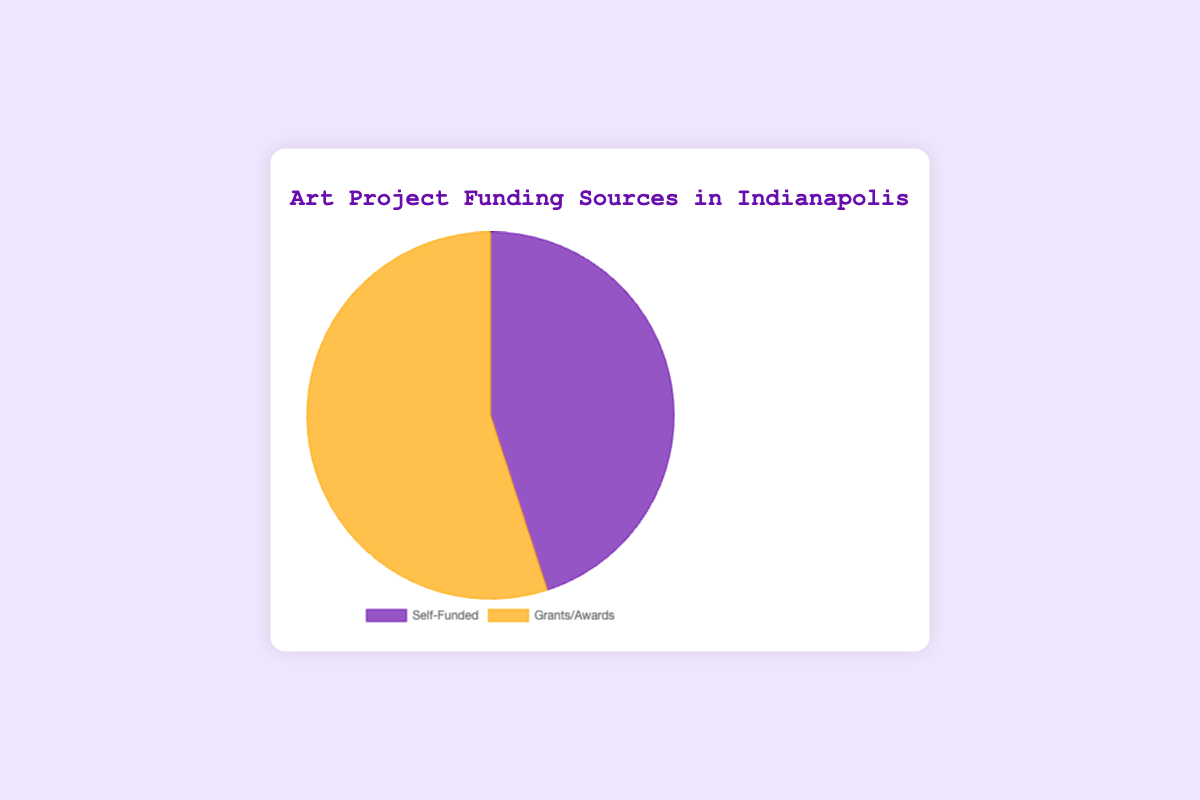Which funding source has a higher percentage? The pie chart divides the funding sources into two parts: Self-Funded and Grants/Awards. The percentage for Grants/Awards is 55%, which is higher than the 45% for Self-Funded.
Answer: Grants/Awards What is the difference in percentage between Grants/Awards and Self-Funded? The percentage for Grants/Awards is 55%, and the percentage for Self-Funded is 45%. The difference is calculated by subtracting the smaller percentage from the larger percentage: 55% - 45% = 10%.
Answer: 10% What is the composition of the funding sources? The chart breaks down the funding into two categories. Grants/Awards make up 55% of the funding sources, while Self-Funded accounts for 45%. Summing up both values confirms that the total is 100%, indicating all data points are included.
Answer: 55% from Grants/Awards and 45% from Self-Funded Is any funding source more than 50%? The pie chart shows that the percentage for Grants/Awards is 55%, which is more than 50%. The percentage for Self-Funded is 45%, which is less than 50%.
Answer: Yes, Grants/Awards Which funding source has a smaller percentage? The pie chart divides the funding sources into Self-Funded with 45% and Grants/Awards with 55%. Self-Funded has the smaller percentage.
Answer: Self-Funded What are the colors used to represent each funding source, and what do they signify? The pie chart uses distinct colors for each funding source. The color for Grants/Awards is orange, and the color for Self-Funded is purple. These colors help viewers easily differentiate between the two funding sources.
Answer: Orange for Grants/Awards, Purple for Self-Funded By how many percentage points is the larger funding source bigger than the other? Grants/Awards constitute 55%, while Self-Funded accounts for 45%. The larger funding source exceeds the other by 55% - 45% = 10 percentage points.
Answer: 10 percentage points 